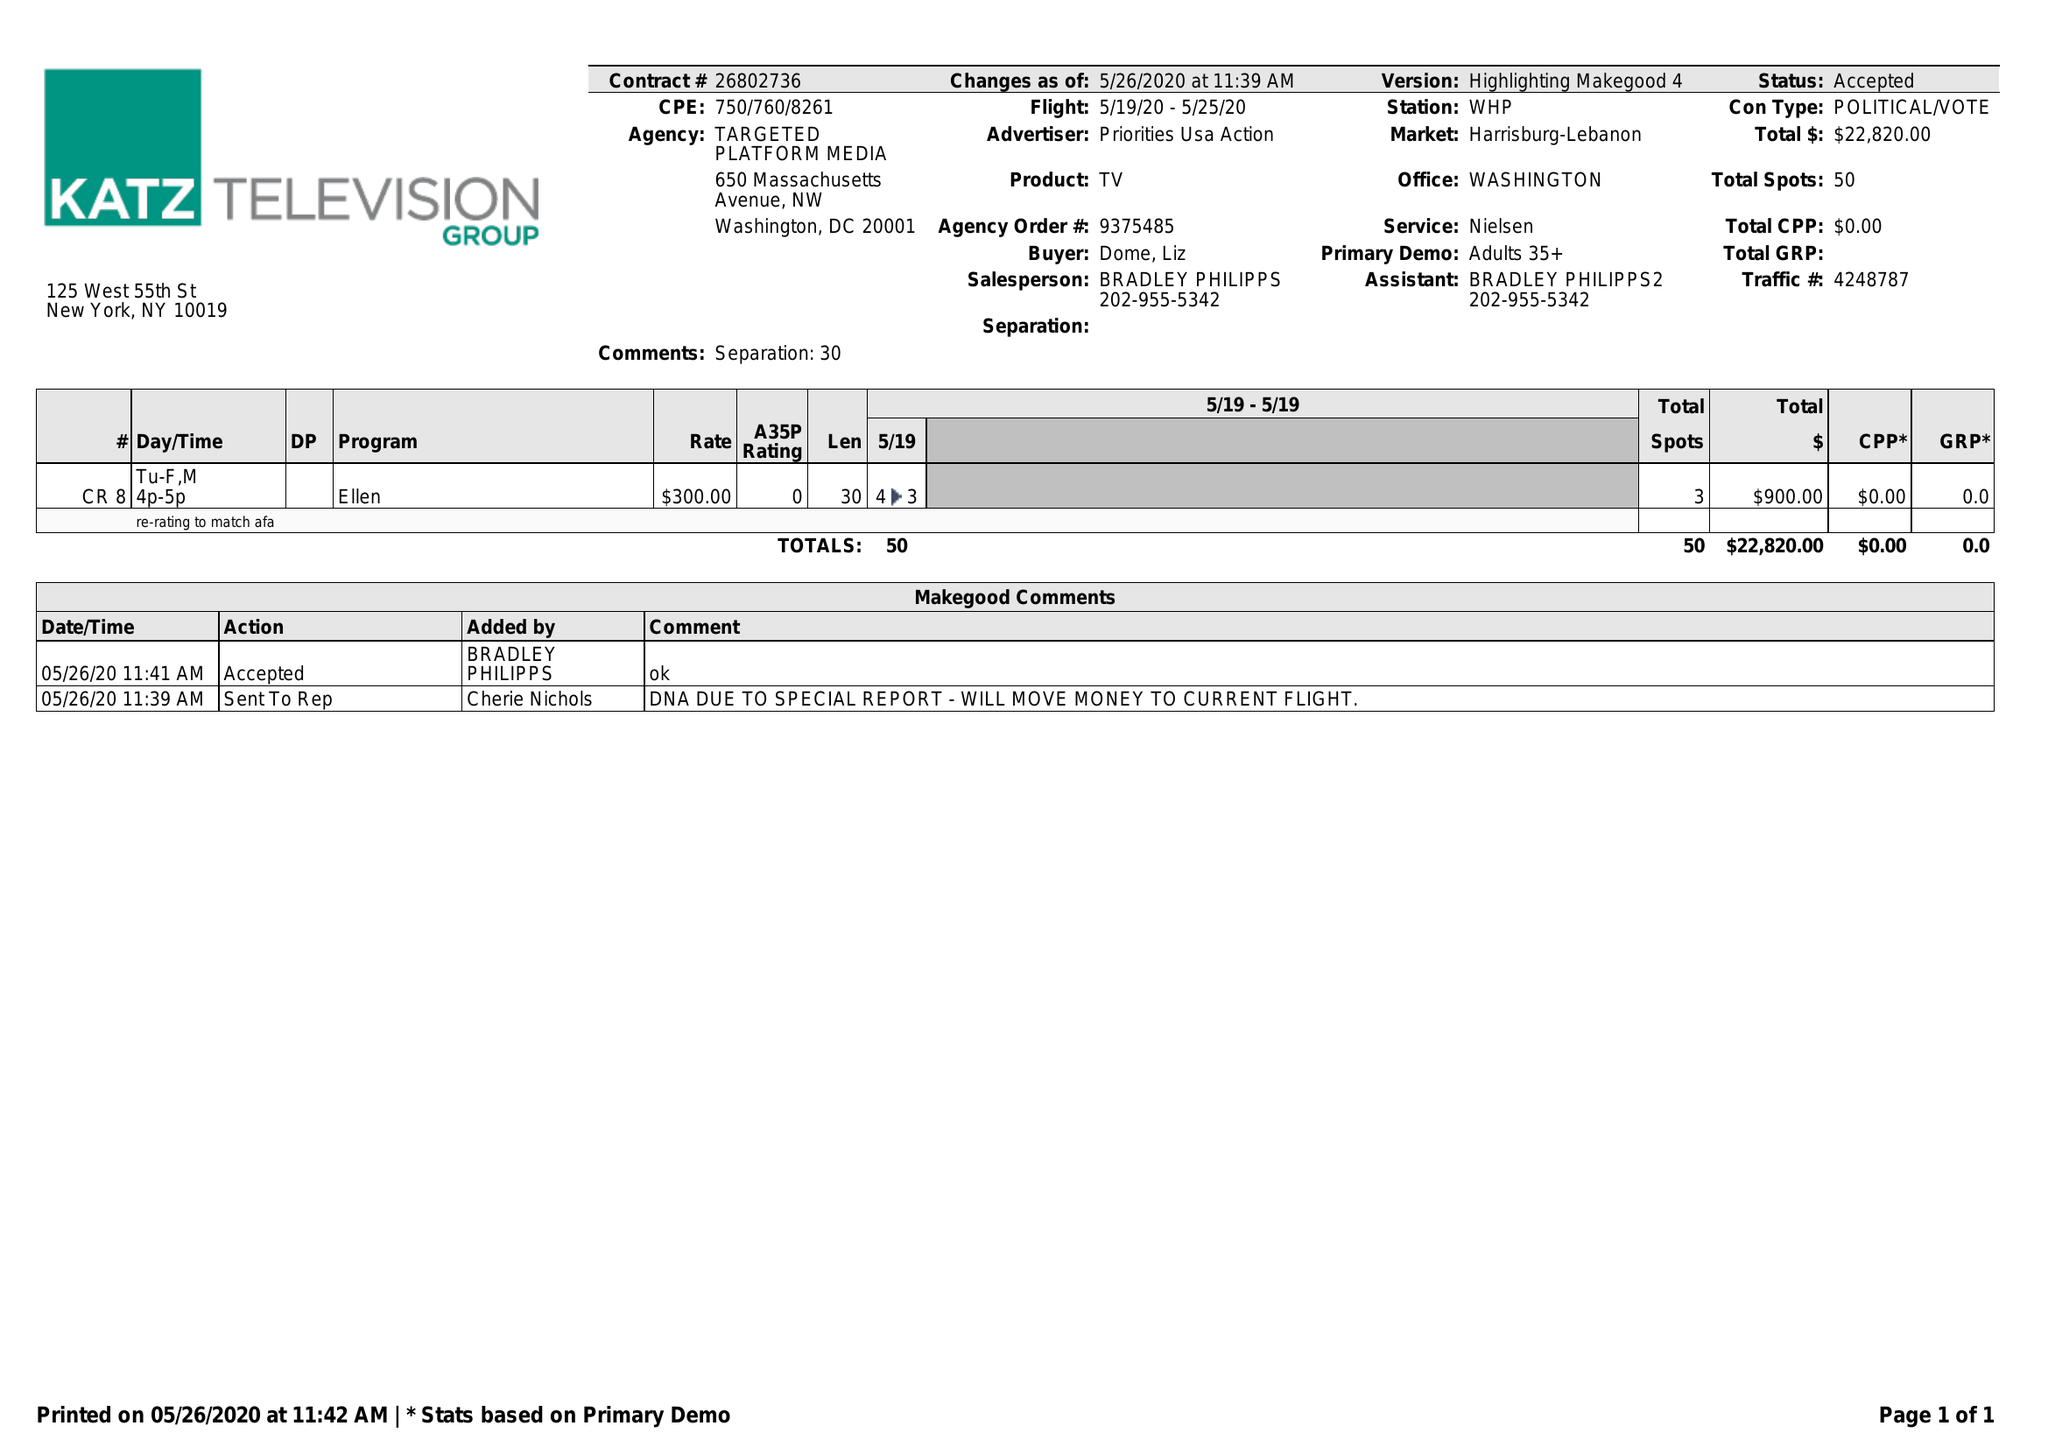What is the value for the contract_num?
Answer the question using a single word or phrase. 26802736 